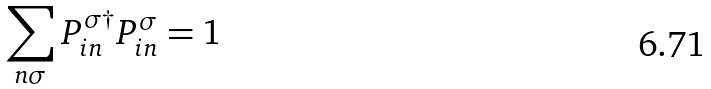<formula> <loc_0><loc_0><loc_500><loc_500>\sum _ { n \sigma } P ^ { \sigma \dagger } _ { i n } P ^ { \sigma } _ { i n } = 1</formula> 